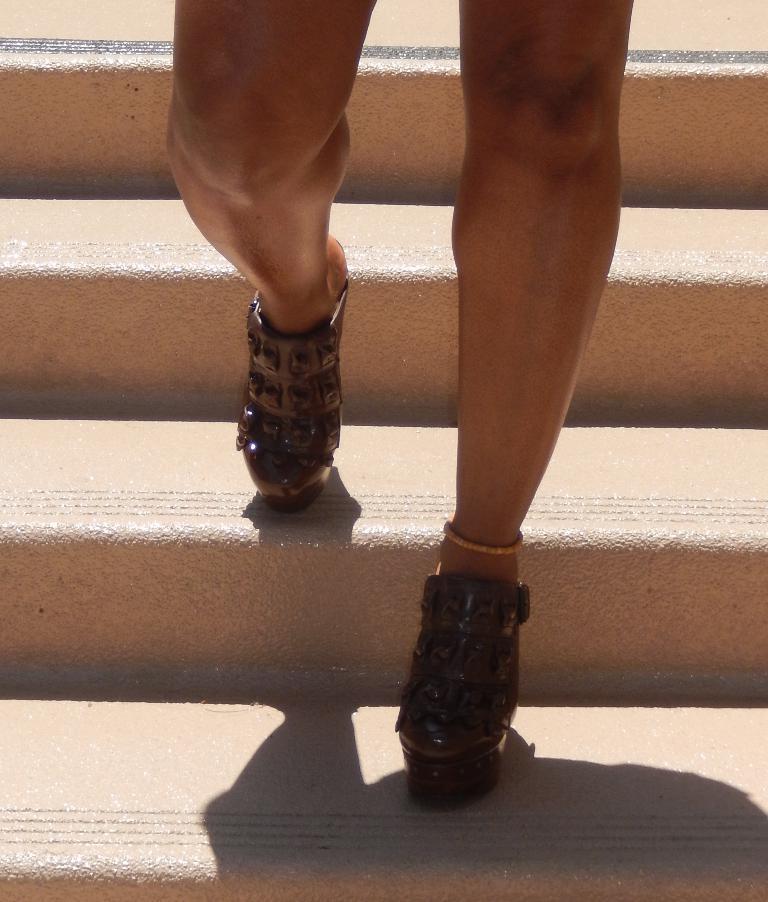Could you give a brief overview of what you see in this image? In the image we can see there is a person standing on the stairs and wearing boots. 